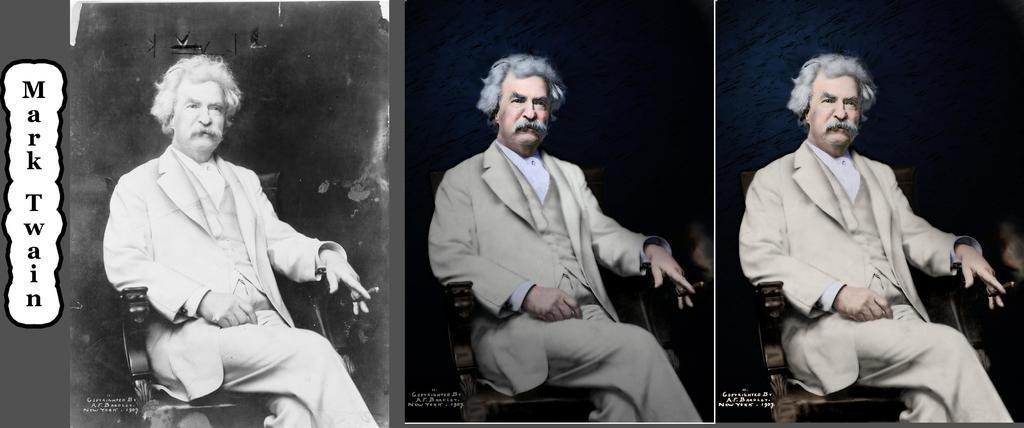Could you give a brief overview of what you see in this image? This image looks like an edited photo in which I can see three persons are sitting on the chairs and walls. 